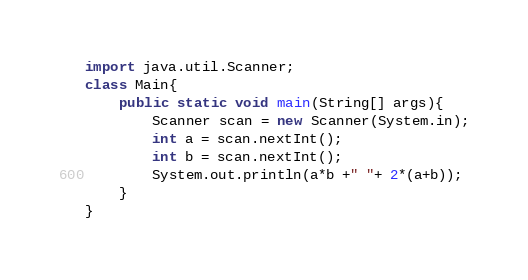<code> <loc_0><loc_0><loc_500><loc_500><_Java_>import java.util.Scanner;
class Main{
	public static void main(String[] args){
		Scanner scan = new Scanner(System.in);
		int a = scan.nextInt();
		int b = scan.nextInt();
		System.out.println(a*b +" "+ 2*(a+b));
	}
}</code> 